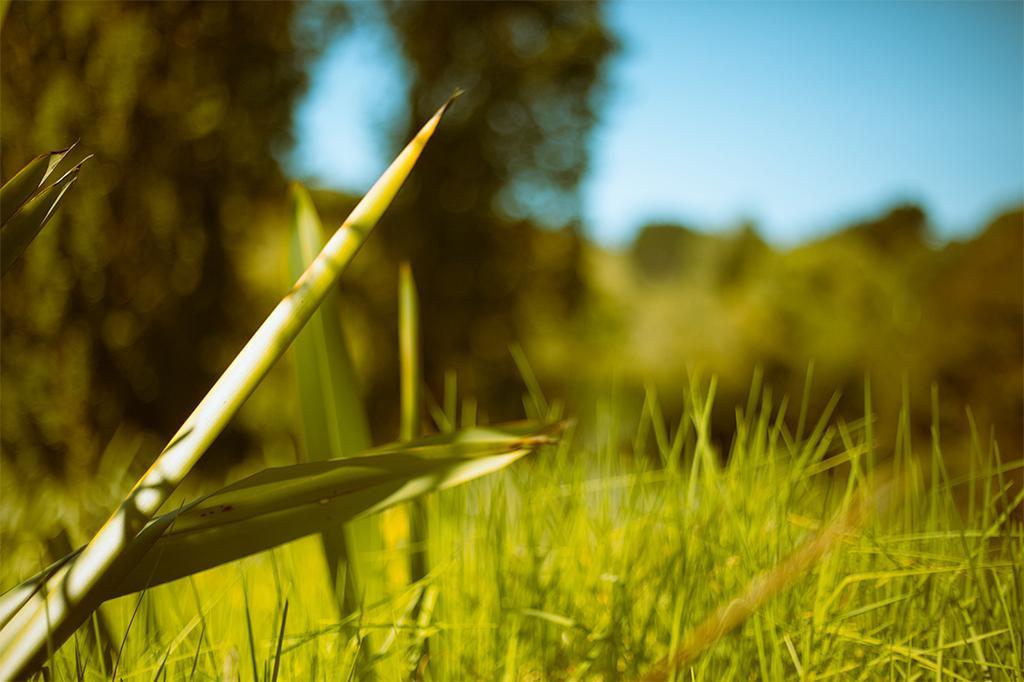Please provide a concise description of this image. Here we can see green grass. In the background it is green and blur and we can see sky. 